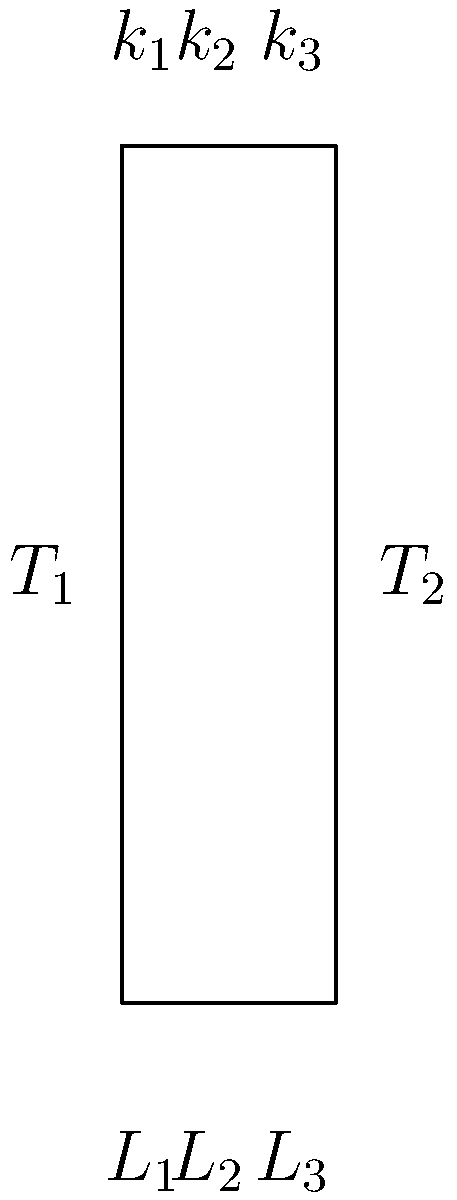As a software developer from 1997, you're working on a simulation of heat transfer through building materials. You encounter a composite wall with three layers, as shown in the diagram. The temperatures on either side of the wall are $T_1 = 25°C$ and $T_2 = -5°C$. The thermal conductivities ($k$) and thicknesses ($L$) of the layers are:

Layer 1: $k_1 = 0.8 \frac{W}{m \cdot K}$, $L_1 = 0.1 m$
Layer 2: $k_2 = 0.05 \frac{W}{m \cdot K}$, $L_2 = 0.2 m$
Layer 3: $k_3 = 0.5 \frac{W}{m \cdot K}$, $L_3 = 0.15 m$

Calculate the heat transfer rate per unit area (in $\frac{W}{m^2}$) through this composite wall. To solve this problem, we'll use the concept of thermal resistance in series. Here's a step-by-step approach:

1) The heat transfer rate per unit area (q) is given by:

   $q = \frac{T_1 - T_2}{R_{total}}$

   where $R_{total}$ is the total thermal resistance of the wall.

2) For a composite wall, the total thermal resistance is the sum of individual layer resistances:

   $R_{total} = R_1 + R_2 + R_3$

3) The thermal resistance for each layer is calculated as:

   $R = \frac{L}{k}$

4) Calculate the resistance for each layer:

   $R_1 = \frac{L_1}{k_1} = \frac{0.1}{0.8} = 0.125 \frac{m^2 \cdot K}{W}$
   
   $R_2 = \frac{L_2}{k_2} = \frac{0.2}{0.05} = 4 \frac{m^2 \cdot K}{W}$
   
   $R_3 = \frac{L_3}{k_3} = \frac{0.15}{0.5} = 0.3 \frac{m^2 \cdot K}{W}$

5) Calculate the total resistance:

   $R_{total} = 0.125 + 4 + 0.3 = 4.425 \frac{m^2 \cdot K}{W}$

6) Now, we can calculate the heat transfer rate:

   $q = \frac{T_1 - T_2}{R_{total}} = \frac{25 - (-5)}{4.425} = \frac{30}{4.425} = 6.78 \frac{W}{m^2}$

Therefore, the heat transfer rate per unit area through the composite wall is approximately 6.78 $\frac{W}{m^2}$.
Answer: 6.78 $\frac{W}{m^2}$ 